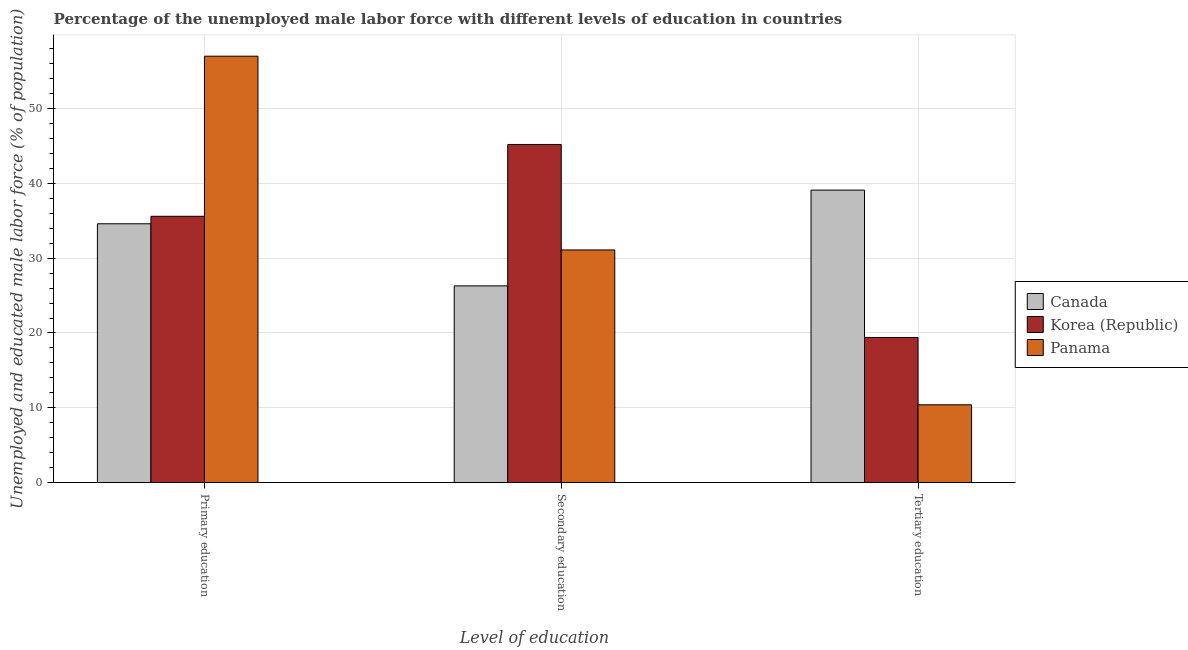How many different coloured bars are there?
Your response must be concise. 3. How many bars are there on the 3rd tick from the left?
Offer a terse response. 3. How many bars are there on the 2nd tick from the right?
Offer a terse response. 3. What is the percentage of male labor force who received primary education in Korea (Republic)?
Provide a short and direct response. 35.6. Across all countries, what is the maximum percentage of male labor force who received secondary education?
Your answer should be compact. 45.2. Across all countries, what is the minimum percentage of male labor force who received tertiary education?
Offer a terse response. 10.4. In which country was the percentage of male labor force who received tertiary education maximum?
Give a very brief answer. Canada. What is the total percentage of male labor force who received secondary education in the graph?
Ensure brevity in your answer.  102.6. What is the difference between the percentage of male labor force who received tertiary education in Canada and that in Korea (Republic)?
Give a very brief answer. 19.7. What is the difference between the percentage of male labor force who received primary education in Canada and the percentage of male labor force who received tertiary education in Korea (Republic)?
Keep it short and to the point. 15.2. What is the average percentage of male labor force who received primary education per country?
Your answer should be compact. 42.4. What is the difference between the percentage of male labor force who received secondary education and percentage of male labor force who received tertiary education in Panama?
Keep it short and to the point. 20.7. What is the ratio of the percentage of male labor force who received tertiary education in Canada to that in Panama?
Make the answer very short. 3.76. Is the percentage of male labor force who received secondary education in Canada less than that in Korea (Republic)?
Your answer should be very brief. Yes. Is the difference between the percentage of male labor force who received secondary education in Canada and Panama greater than the difference between the percentage of male labor force who received tertiary education in Canada and Panama?
Provide a short and direct response. No. What is the difference between the highest and the second highest percentage of male labor force who received primary education?
Offer a very short reply. 21.4. What is the difference between the highest and the lowest percentage of male labor force who received primary education?
Keep it short and to the point. 22.4. What does the 3rd bar from the left in Secondary education represents?
Provide a short and direct response. Panama. What does the 1st bar from the right in Primary education represents?
Provide a short and direct response. Panama. Is it the case that in every country, the sum of the percentage of male labor force who received primary education and percentage of male labor force who received secondary education is greater than the percentage of male labor force who received tertiary education?
Provide a succinct answer. Yes. How many bars are there?
Your response must be concise. 9. Are all the bars in the graph horizontal?
Provide a short and direct response. No. Are the values on the major ticks of Y-axis written in scientific E-notation?
Offer a terse response. No. Does the graph contain any zero values?
Offer a very short reply. No. Where does the legend appear in the graph?
Offer a very short reply. Center right. What is the title of the graph?
Your response must be concise. Percentage of the unemployed male labor force with different levels of education in countries. Does "Pakistan" appear as one of the legend labels in the graph?
Your response must be concise. No. What is the label or title of the X-axis?
Your response must be concise. Level of education. What is the label or title of the Y-axis?
Offer a terse response. Unemployed and educated male labor force (% of population). What is the Unemployed and educated male labor force (% of population) in Canada in Primary education?
Your answer should be very brief. 34.6. What is the Unemployed and educated male labor force (% of population) in Korea (Republic) in Primary education?
Keep it short and to the point. 35.6. What is the Unemployed and educated male labor force (% of population) of Panama in Primary education?
Offer a very short reply. 57. What is the Unemployed and educated male labor force (% of population) in Canada in Secondary education?
Your answer should be compact. 26.3. What is the Unemployed and educated male labor force (% of population) of Korea (Republic) in Secondary education?
Your answer should be very brief. 45.2. What is the Unemployed and educated male labor force (% of population) of Panama in Secondary education?
Ensure brevity in your answer.  31.1. What is the Unemployed and educated male labor force (% of population) of Canada in Tertiary education?
Provide a short and direct response. 39.1. What is the Unemployed and educated male labor force (% of population) of Korea (Republic) in Tertiary education?
Ensure brevity in your answer.  19.4. What is the Unemployed and educated male labor force (% of population) in Panama in Tertiary education?
Ensure brevity in your answer.  10.4. Across all Level of education, what is the maximum Unemployed and educated male labor force (% of population) in Canada?
Your answer should be very brief. 39.1. Across all Level of education, what is the maximum Unemployed and educated male labor force (% of population) of Korea (Republic)?
Your answer should be compact. 45.2. Across all Level of education, what is the maximum Unemployed and educated male labor force (% of population) of Panama?
Offer a terse response. 57. Across all Level of education, what is the minimum Unemployed and educated male labor force (% of population) of Canada?
Your response must be concise. 26.3. Across all Level of education, what is the minimum Unemployed and educated male labor force (% of population) in Korea (Republic)?
Your answer should be very brief. 19.4. Across all Level of education, what is the minimum Unemployed and educated male labor force (% of population) in Panama?
Your answer should be compact. 10.4. What is the total Unemployed and educated male labor force (% of population) of Canada in the graph?
Ensure brevity in your answer.  100. What is the total Unemployed and educated male labor force (% of population) of Korea (Republic) in the graph?
Ensure brevity in your answer.  100.2. What is the total Unemployed and educated male labor force (% of population) in Panama in the graph?
Your response must be concise. 98.5. What is the difference between the Unemployed and educated male labor force (% of population) of Canada in Primary education and that in Secondary education?
Provide a succinct answer. 8.3. What is the difference between the Unemployed and educated male labor force (% of population) of Korea (Republic) in Primary education and that in Secondary education?
Make the answer very short. -9.6. What is the difference between the Unemployed and educated male labor force (% of population) in Panama in Primary education and that in Secondary education?
Offer a very short reply. 25.9. What is the difference between the Unemployed and educated male labor force (% of population) in Panama in Primary education and that in Tertiary education?
Make the answer very short. 46.6. What is the difference between the Unemployed and educated male labor force (% of population) of Korea (Republic) in Secondary education and that in Tertiary education?
Make the answer very short. 25.8. What is the difference between the Unemployed and educated male labor force (% of population) of Panama in Secondary education and that in Tertiary education?
Offer a very short reply. 20.7. What is the difference between the Unemployed and educated male labor force (% of population) of Canada in Primary education and the Unemployed and educated male labor force (% of population) of Korea (Republic) in Secondary education?
Ensure brevity in your answer.  -10.6. What is the difference between the Unemployed and educated male labor force (% of population) in Canada in Primary education and the Unemployed and educated male labor force (% of population) in Panama in Tertiary education?
Ensure brevity in your answer.  24.2. What is the difference between the Unemployed and educated male labor force (% of population) of Korea (Republic) in Primary education and the Unemployed and educated male labor force (% of population) of Panama in Tertiary education?
Make the answer very short. 25.2. What is the difference between the Unemployed and educated male labor force (% of population) in Canada in Secondary education and the Unemployed and educated male labor force (% of population) in Korea (Republic) in Tertiary education?
Your response must be concise. 6.9. What is the difference between the Unemployed and educated male labor force (% of population) of Korea (Republic) in Secondary education and the Unemployed and educated male labor force (% of population) of Panama in Tertiary education?
Ensure brevity in your answer.  34.8. What is the average Unemployed and educated male labor force (% of population) of Canada per Level of education?
Offer a terse response. 33.33. What is the average Unemployed and educated male labor force (% of population) of Korea (Republic) per Level of education?
Ensure brevity in your answer.  33.4. What is the average Unemployed and educated male labor force (% of population) of Panama per Level of education?
Offer a very short reply. 32.83. What is the difference between the Unemployed and educated male labor force (% of population) in Canada and Unemployed and educated male labor force (% of population) in Panama in Primary education?
Your answer should be compact. -22.4. What is the difference between the Unemployed and educated male labor force (% of population) of Korea (Republic) and Unemployed and educated male labor force (% of population) of Panama in Primary education?
Keep it short and to the point. -21.4. What is the difference between the Unemployed and educated male labor force (% of population) of Canada and Unemployed and educated male labor force (% of population) of Korea (Republic) in Secondary education?
Keep it short and to the point. -18.9. What is the difference between the Unemployed and educated male labor force (% of population) of Canada and Unemployed and educated male labor force (% of population) of Panama in Tertiary education?
Your response must be concise. 28.7. What is the difference between the Unemployed and educated male labor force (% of population) of Korea (Republic) and Unemployed and educated male labor force (% of population) of Panama in Tertiary education?
Your response must be concise. 9. What is the ratio of the Unemployed and educated male labor force (% of population) in Canada in Primary education to that in Secondary education?
Your answer should be very brief. 1.32. What is the ratio of the Unemployed and educated male labor force (% of population) of Korea (Republic) in Primary education to that in Secondary education?
Your answer should be very brief. 0.79. What is the ratio of the Unemployed and educated male labor force (% of population) of Panama in Primary education to that in Secondary education?
Keep it short and to the point. 1.83. What is the ratio of the Unemployed and educated male labor force (% of population) in Canada in Primary education to that in Tertiary education?
Keep it short and to the point. 0.88. What is the ratio of the Unemployed and educated male labor force (% of population) of Korea (Republic) in Primary education to that in Tertiary education?
Your answer should be compact. 1.84. What is the ratio of the Unemployed and educated male labor force (% of population) in Panama in Primary education to that in Tertiary education?
Offer a very short reply. 5.48. What is the ratio of the Unemployed and educated male labor force (% of population) in Canada in Secondary education to that in Tertiary education?
Give a very brief answer. 0.67. What is the ratio of the Unemployed and educated male labor force (% of population) of Korea (Republic) in Secondary education to that in Tertiary education?
Give a very brief answer. 2.33. What is the ratio of the Unemployed and educated male labor force (% of population) of Panama in Secondary education to that in Tertiary education?
Provide a succinct answer. 2.99. What is the difference between the highest and the second highest Unemployed and educated male labor force (% of population) of Canada?
Your response must be concise. 4.5. What is the difference between the highest and the second highest Unemployed and educated male labor force (% of population) of Panama?
Provide a succinct answer. 25.9. What is the difference between the highest and the lowest Unemployed and educated male labor force (% of population) in Canada?
Your answer should be very brief. 12.8. What is the difference between the highest and the lowest Unemployed and educated male labor force (% of population) in Korea (Republic)?
Provide a succinct answer. 25.8. What is the difference between the highest and the lowest Unemployed and educated male labor force (% of population) in Panama?
Offer a terse response. 46.6. 